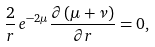Convert formula to latex. <formula><loc_0><loc_0><loc_500><loc_500>\frac { 2 } { r } \, e ^ { - 2 \mu } \frac { \partial \left ( \mu + \nu \right ) } { \partial r } = 0 ,</formula> 